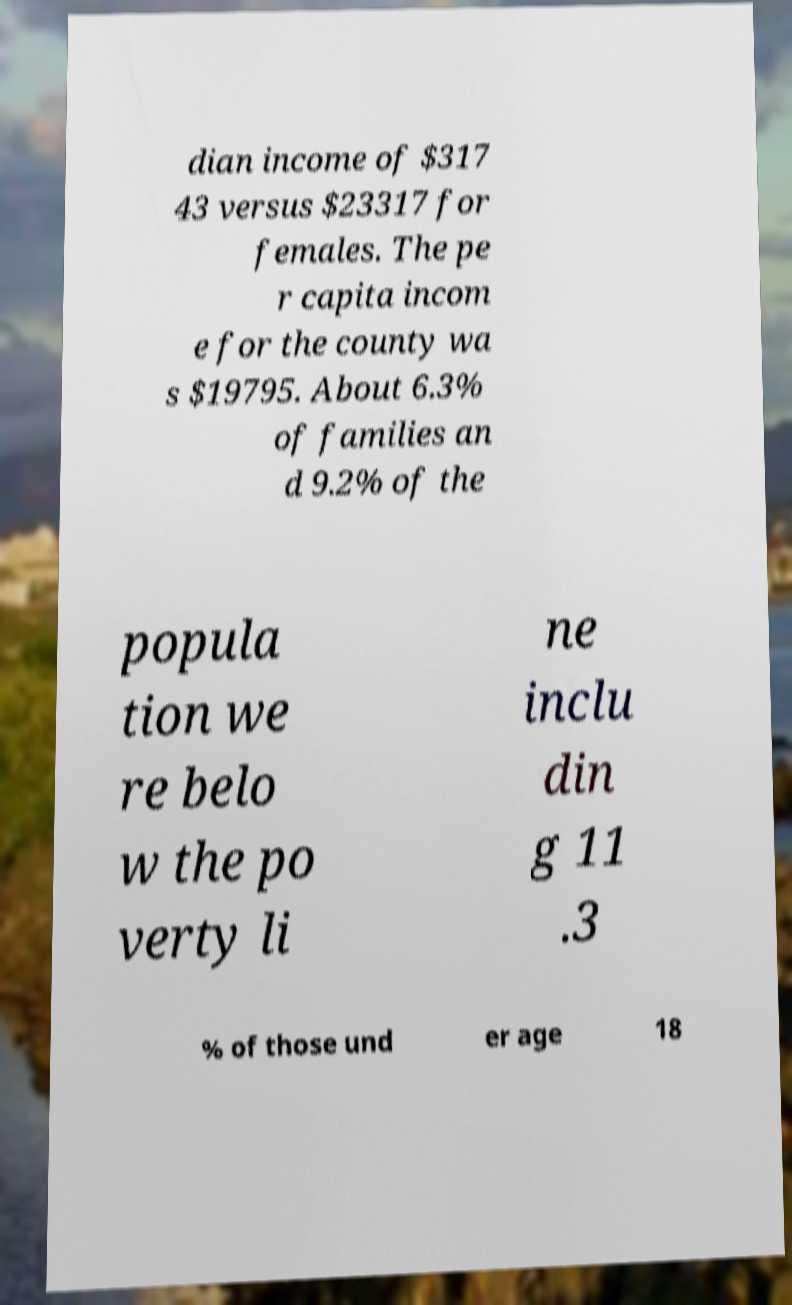Please identify and transcribe the text found in this image. dian income of $317 43 versus $23317 for females. The pe r capita incom e for the county wa s $19795. About 6.3% of families an d 9.2% of the popula tion we re belo w the po verty li ne inclu din g 11 .3 % of those und er age 18 